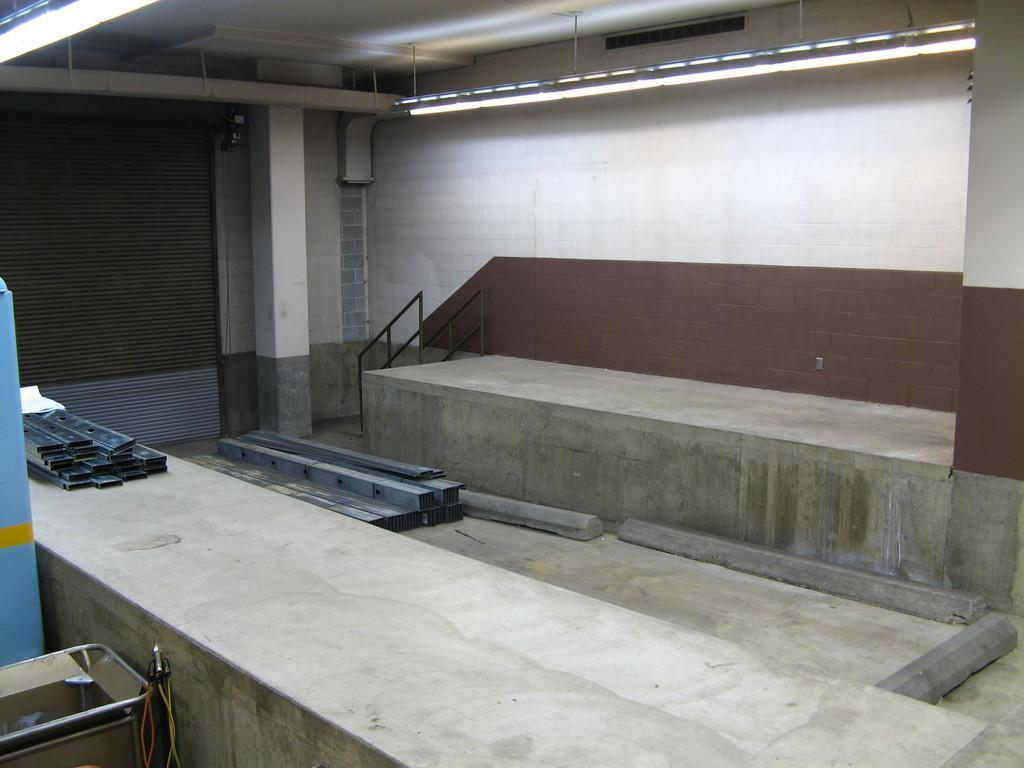Could you give a brief overview of what you see in this image? There is a platform at the bottom of this image. We can see railing and a wall in the middle of this image. We can see a shutter on the left side of this image and a light is at the top of this image. 